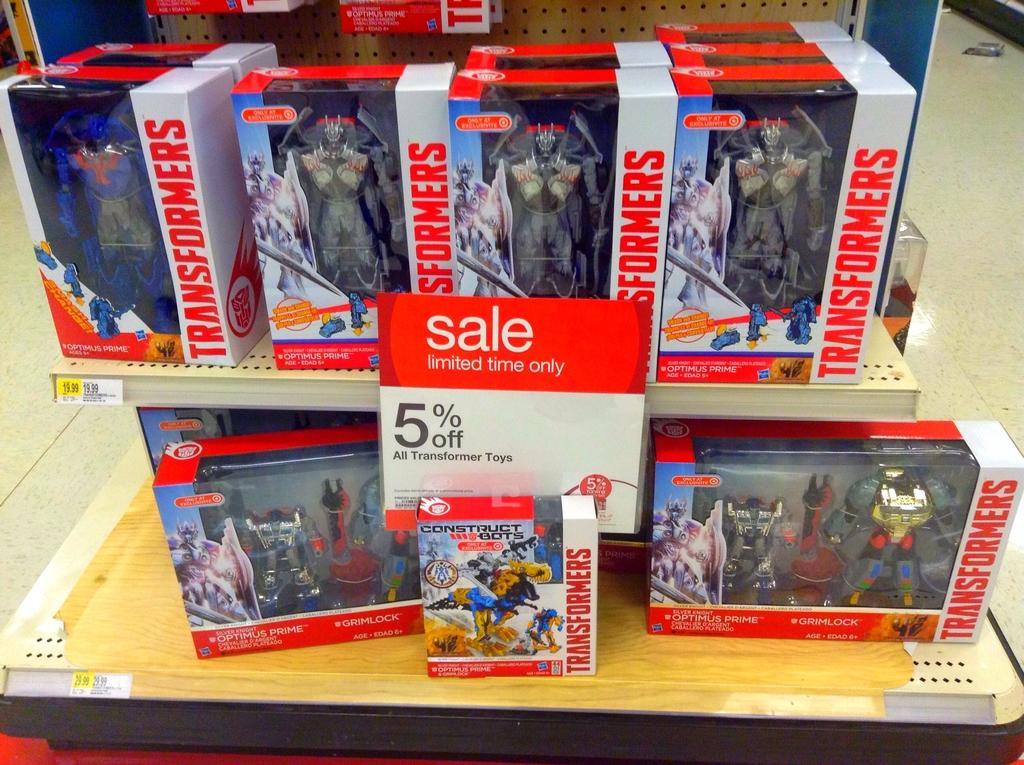In one or two sentences, can you explain what this image depicts? In this image we can see a wooden stand. On that there are boxes. On the boxes there is text. There are toys in the boxes. 